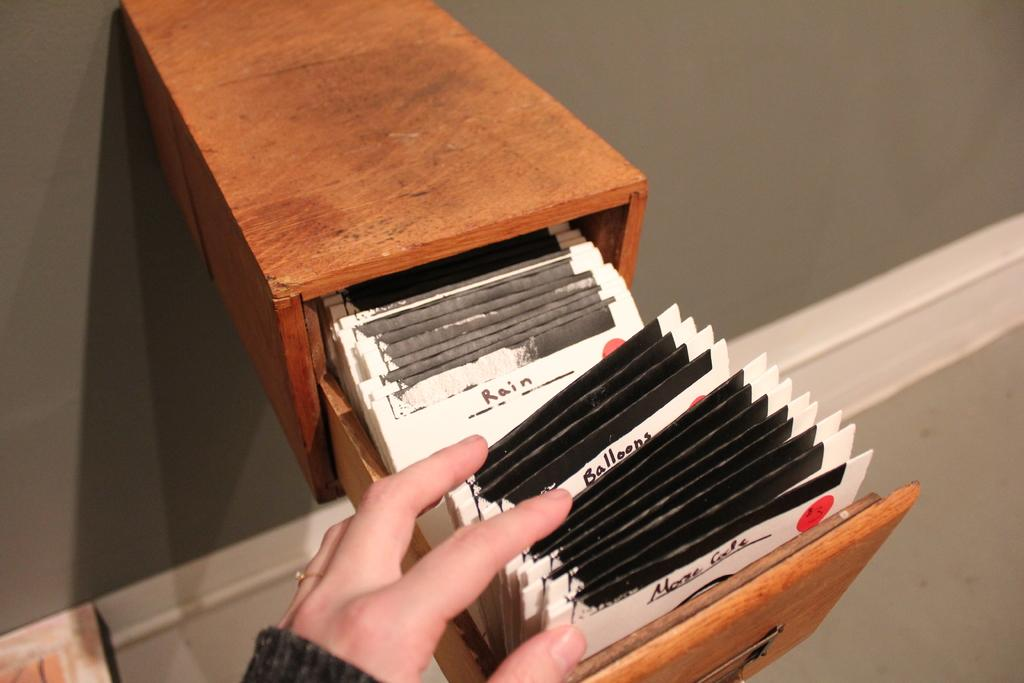What is attached to the wall in the image? There is a box with a drawer attached to the wall in the image. What can be found inside the box? There are packets inside the box. Whose hand is visible in the image? The hand of a person is visible in the image. What type of beam is being used to support the house in the image? There is no house or beam present in the image; it only features a box with a drawer and packets inside. Is there a boot visible in the image? No, there is no boot present in the image. 